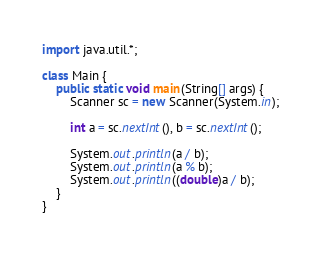Convert code to text. <code><loc_0><loc_0><loc_500><loc_500><_Java_>import java.util.*;

class Main {
	public static void main(String[] args) {
		Scanner sc = new Scanner(System.in);

		int a = sc.nextInt(), b = sc.nextInt();
		
		System.out.println(a / b);
		System.out.println(a % b);
		System.out.println((double)a / b);
	}
}</code> 